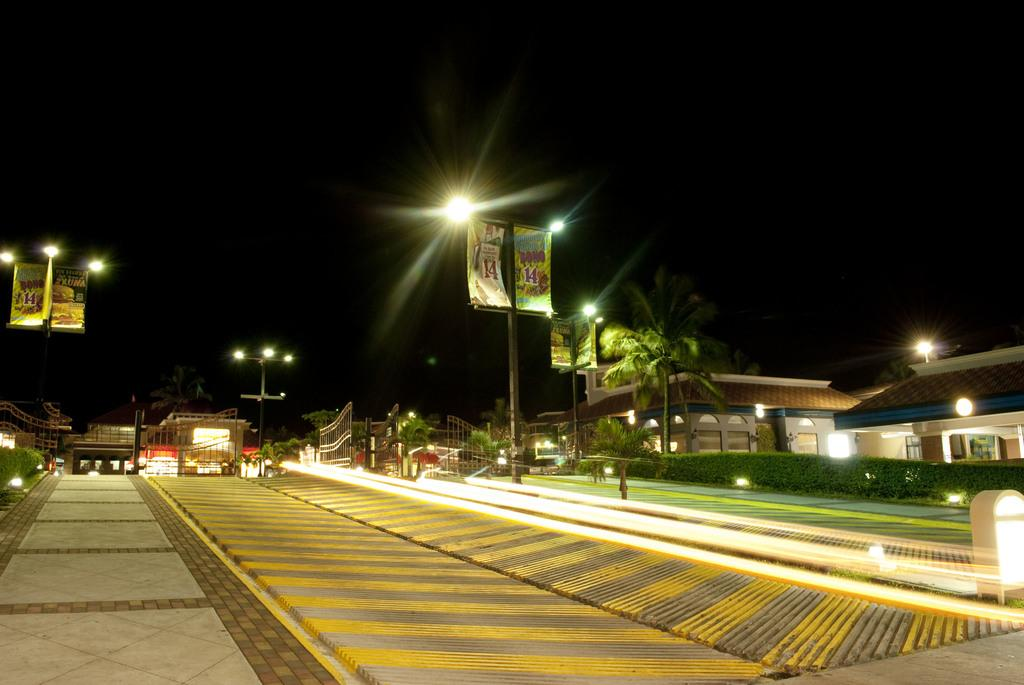What structures are present in the image? There are poles, lights, hoardings, gates, and houses in the image. What type of vegetation can be seen in the image? There are plants and trees in the image. What is the primary function of the poles in the image? The poles are likely used to support the lights or other structures in the image. What is the background of the image? The sky is visible in the background of the image. Is there a rainbow visible in the image? There is no mention of a rainbow in the provided facts, so we cannot determine if one is present in the image. How many trees are there in the image? The provided facts do not specify the exact number of trees in the image, only that there are trees present. 